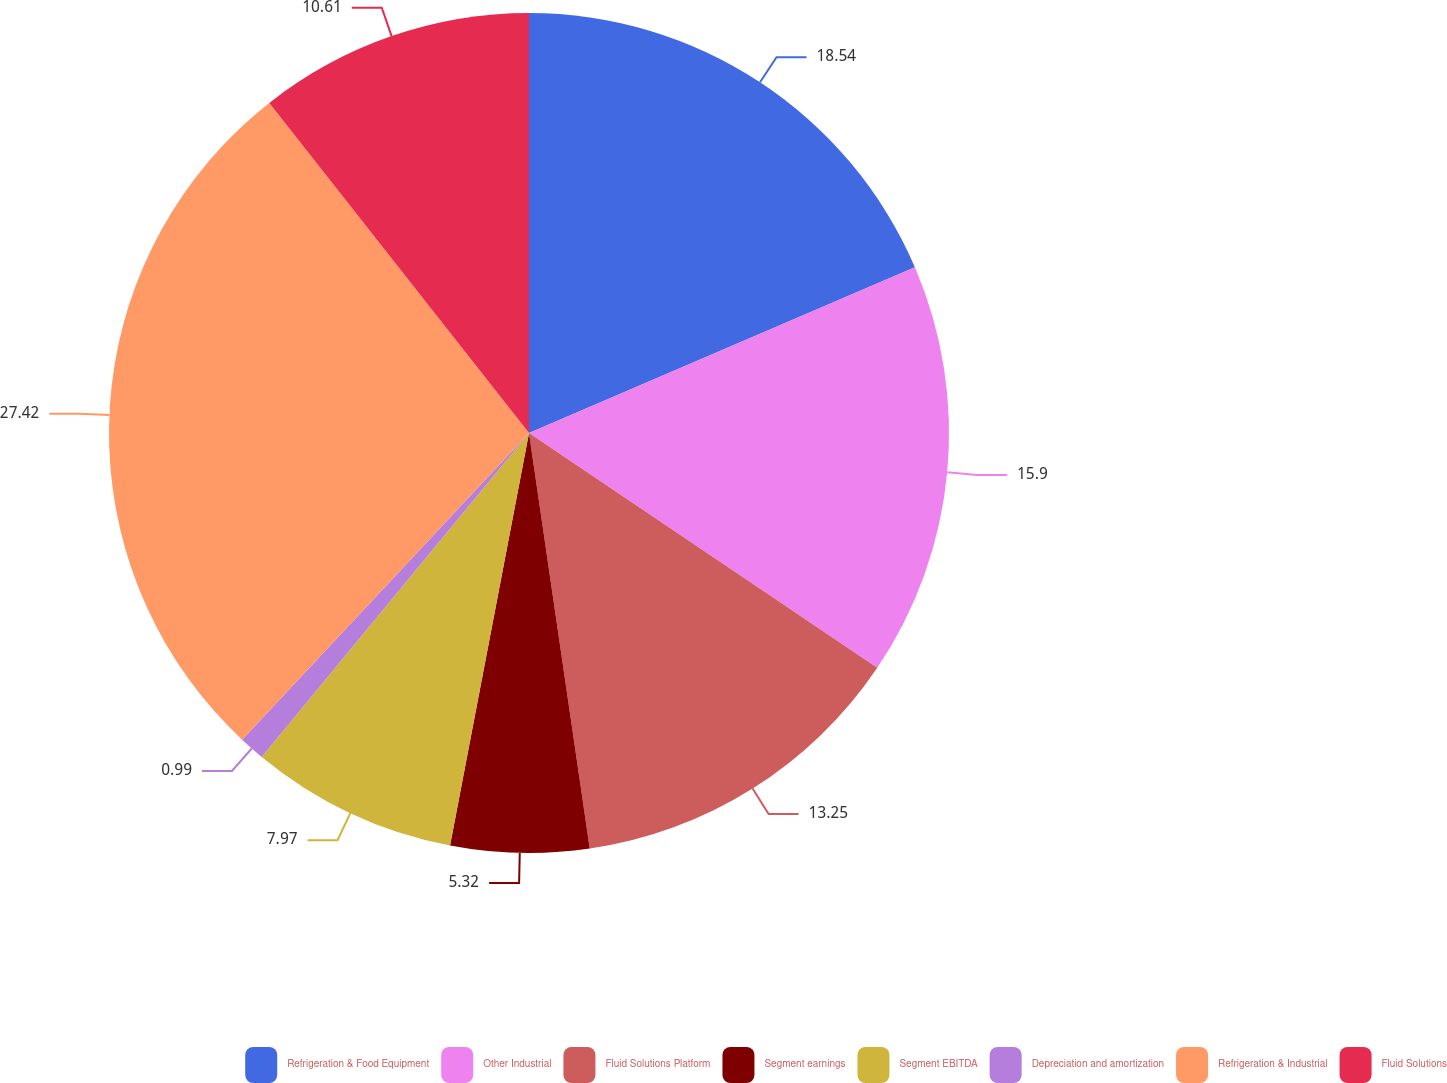Convert chart to OTSL. <chart><loc_0><loc_0><loc_500><loc_500><pie_chart><fcel>Refrigeration & Food Equipment<fcel>Other Industrial<fcel>Fluid Solutions Platform<fcel>Segment earnings<fcel>Segment EBITDA<fcel>Depreciation and amortization<fcel>Refrigeration & Industrial<fcel>Fluid Solutions<nl><fcel>18.54%<fcel>15.9%<fcel>13.25%<fcel>5.32%<fcel>7.97%<fcel>0.99%<fcel>27.42%<fcel>10.61%<nl></chart> 